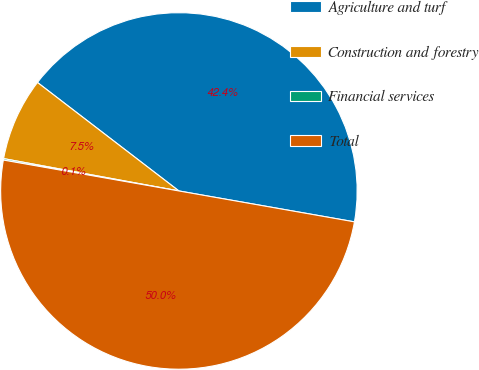Convert chart to OTSL. <chart><loc_0><loc_0><loc_500><loc_500><pie_chart><fcel>Agriculture and turf<fcel>Construction and forestry<fcel>Financial services<fcel>Total<nl><fcel>42.36%<fcel>7.51%<fcel>0.13%<fcel>50.0%<nl></chart> 